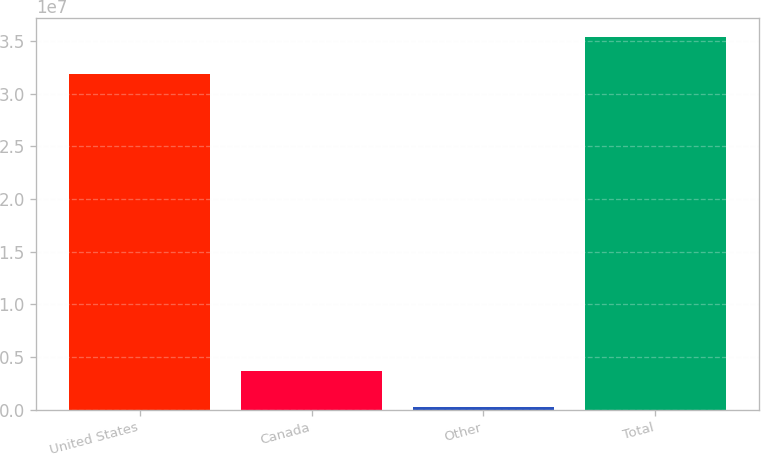Convert chart. <chart><loc_0><loc_0><loc_500><loc_500><bar_chart><fcel>United States<fcel>Canada<fcel>Other<fcel>Total<nl><fcel>3.18912e+07<fcel>3.70921e+06<fcel>227783<fcel>3.53726e+07<nl></chart> 